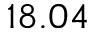<formula> <loc_0><loc_0><loc_500><loc_500>1 8 . 0 4</formula> 